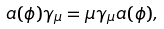<formula> <loc_0><loc_0><loc_500><loc_500>a ( \phi ) \gamma _ { \mu } = \mu \gamma _ { \mu } a ( \phi ) ,</formula> 